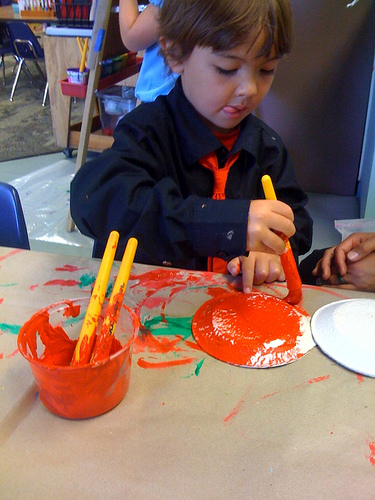What does the choice of color in the painting suggest about the child's preferences? While it's difficult to ascertain the child's preferences from a single image, the prominent use of red paint might suggest that the child has a preference for bold and vivid colors, or it could simply be the color chosen for that specific part of the artwork. Could the child's attire give us any hints about the weather or the season? The child's attire, which includes a long-sleeved jacket, implies that the weather might be on the cooler side, typical of autumn or spring, or that the indoor setting is air-conditioned. 